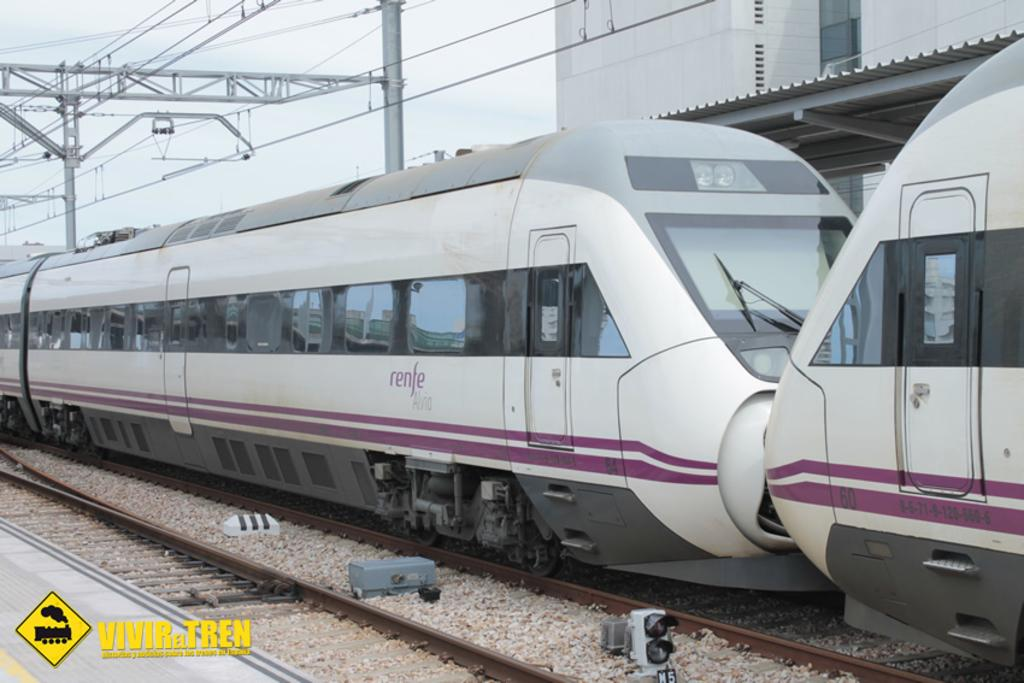<image>
Render a clear and concise summary of the photo. a train with the word vivir next to it 